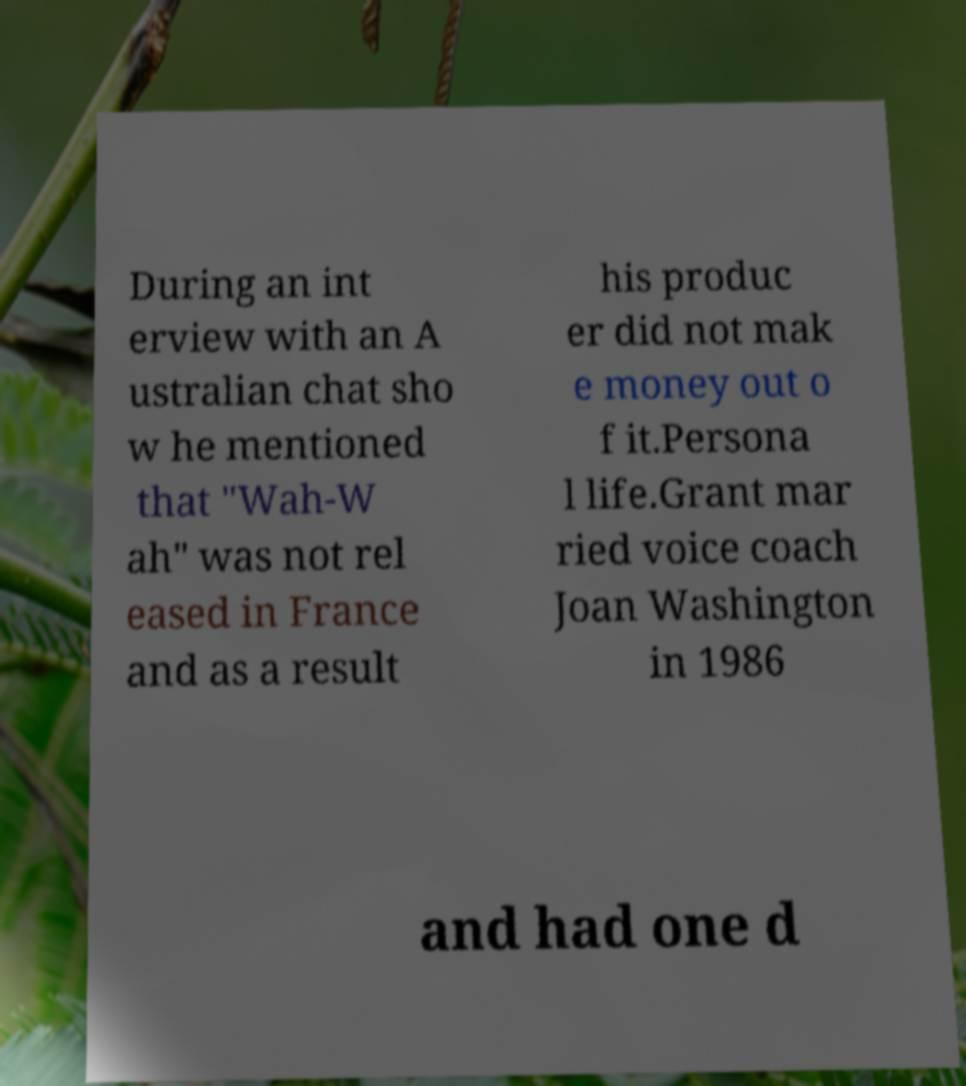Can you accurately transcribe the text from the provided image for me? During an int erview with an A ustralian chat sho w he mentioned that "Wah-W ah" was not rel eased in France and as a result his produc er did not mak e money out o f it.Persona l life.Grant mar ried voice coach Joan Washington in 1986 and had one d 